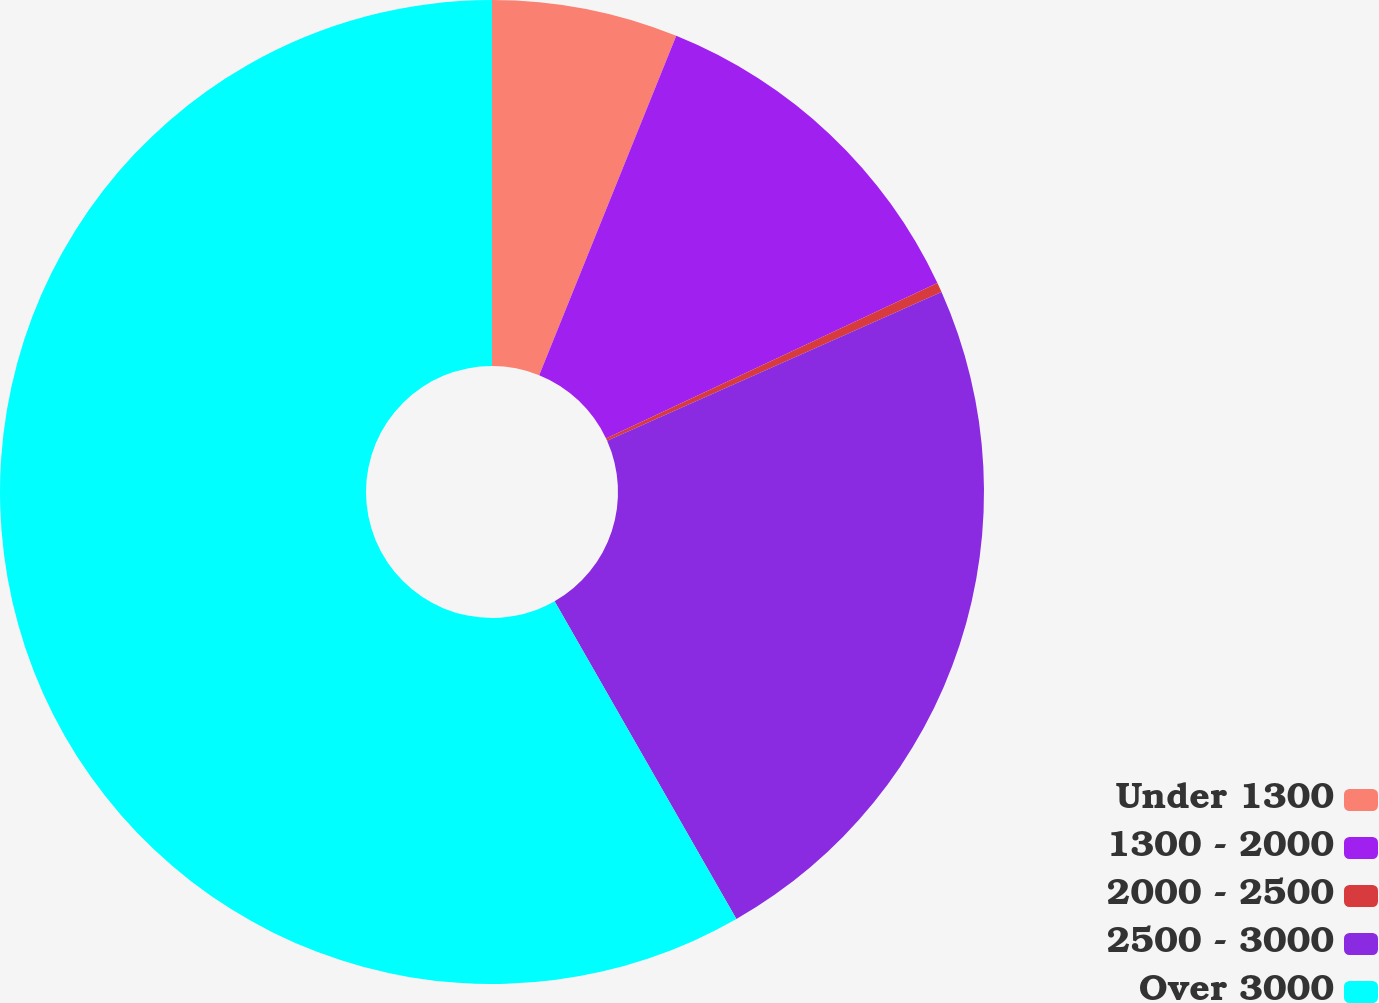Convert chart to OTSL. <chart><loc_0><loc_0><loc_500><loc_500><pie_chart><fcel>Under 1300<fcel>1300 - 2000<fcel>2000 - 2500<fcel>2500 - 3000<fcel>Over 3000<nl><fcel>6.11%<fcel>11.91%<fcel>0.32%<fcel>23.39%<fcel>58.28%<nl></chart> 